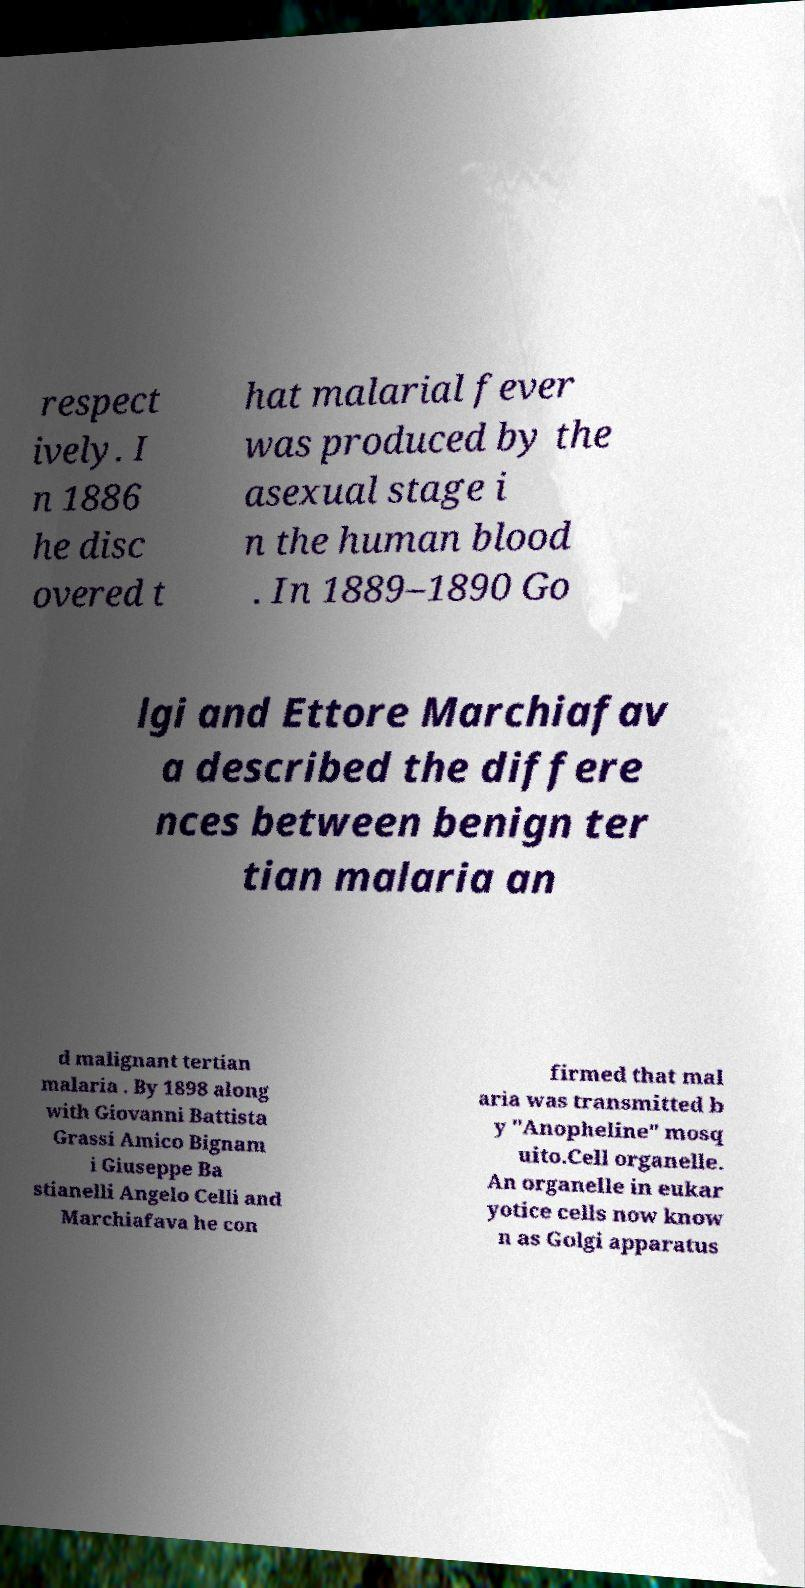For documentation purposes, I need the text within this image transcribed. Could you provide that? respect ively. I n 1886 he disc overed t hat malarial fever was produced by the asexual stage i n the human blood . In 1889–1890 Go lgi and Ettore Marchiafav a described the differe nces between benign ter tian malaria an d malignant tertian malaria . By 1898 along with Giovanni Battista Grassi Amico Bignam i Giuseppe Ba stianelli Angelo Celli and Marchiafava he con firmed that mal aria was transmitted b y "Anopheline" mosq uito.Cell organelle. An organelle in eukar yotice cells now know n as Golgi apparatus 